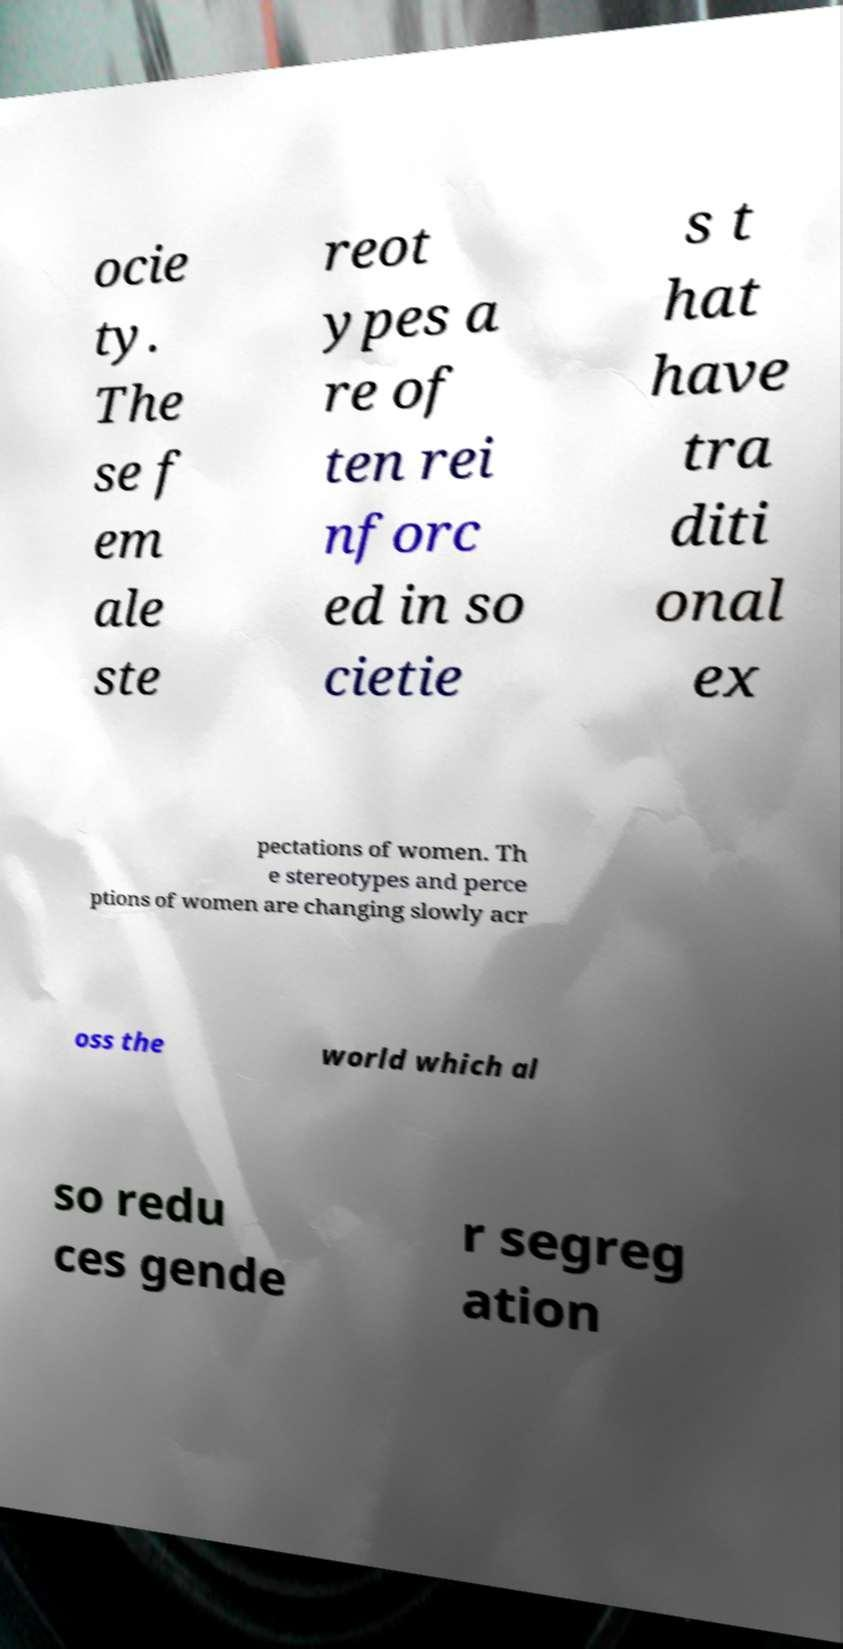Can you read and provide the text displayed in the image?This photo seems to have some interesting text. Can you extract and type it out for me? ocie ty. The se f em ale ste reot ypes a re of ten rei nforc ed in so cietie s t hat have tra diti onal ex pectations of women. Th e stereotypes and perce ptions of women are changing slowly acr oss the world which al so redu ces gende r segreg ation 